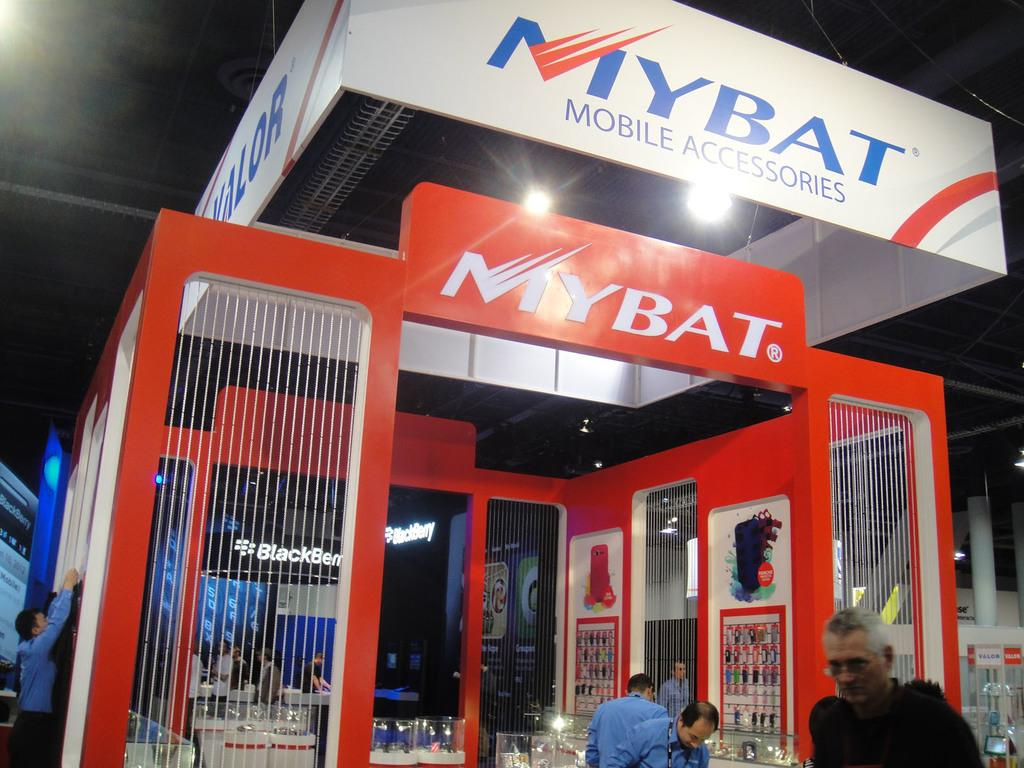Who or what can be seen in the image? There are people in the image. What type of establishment is visible in the image? There is a store in the image. What kind of signage is present in the image? There are hoardings in the image. What can be used for illumination in the image? There are lights in the image. What architectural features can be seen in the background of the image? There are pillars in the background of the image. What is present in the background of the image for displaying information? There is a board in the background of the image. What can be used for illumination in the background of the image? There are lights in the background of the image. Reasoning: Let' Let's think step by step in order to produce the conversation. We start by identifying the main subjects and objects in the image based on the provided facts. We then formulate questions that focus on the location and characteristics of these subjects and objects, ensuring that each question can be answered definitively with the information given. We avoid yes/no questions and ensure that the language is simple and clear. Absurd Question/Answer: What type of fang can be seen in the image? There is no fang present in the image. What is the taste of the board in the background of the image? The board in the background of the image does not have a taste, as it is not an edible object. --- Facts: 1. There is a car in the image. 2. The car is red. 3. The car has four wheels. 4. There is a road in the image. 5. The road is paved. 6. There are trees in the background of the image. Absurd Topics: unicorn, dance, melody Conversation: What is the main subject of the image? The main subject of the image is a car. What color is the car? The car is red. How many wheels does the car have? The car has four wheels. What type of surface is the car on in the image? There is a road in the image, and it is paved. What can be seen in the background of the image? There are trees in the background of the image. Can you hear the melody of the unicorn in the image? There is no unicorn or melody present in the image. What dance style is the car performing in the image? Cars do not perform dances, as they are inanimate objects. 